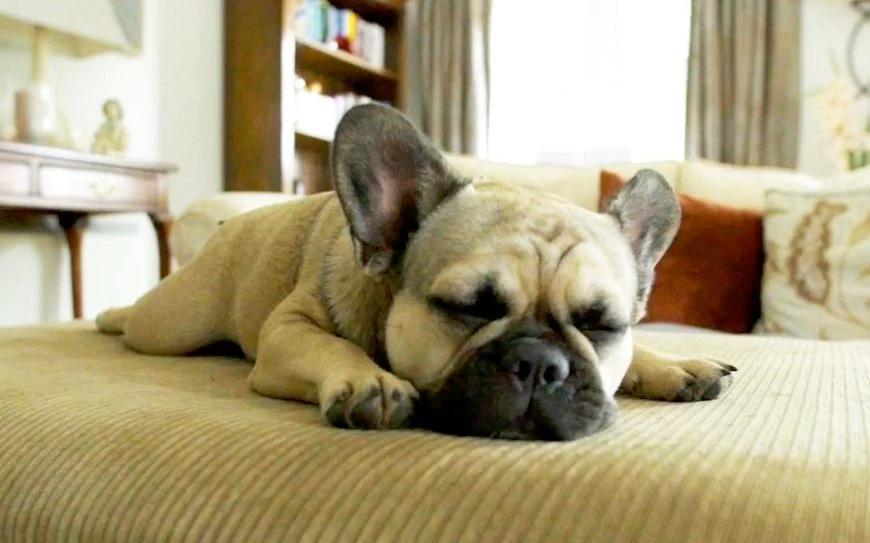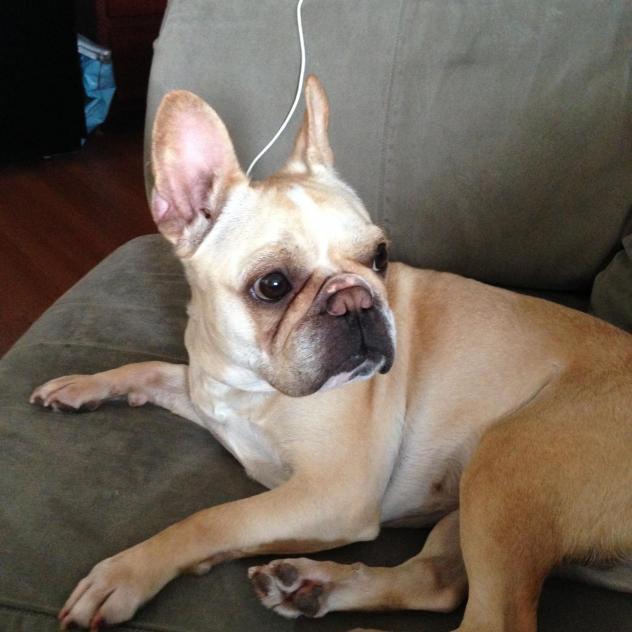The first image is the image on the left, the second image is the image on the right. Evaluate the accuracy of this statement regarding the images: "There is one dog lying on a wood floor.". Is it true? Answer yes or no. No. The first image is the image on the left, the second image is the image on the right. Assess this claim about the two images: "One of the dogs has its head resting directly on a cushion.". Correct or not? Answer yes or no. Yes. 